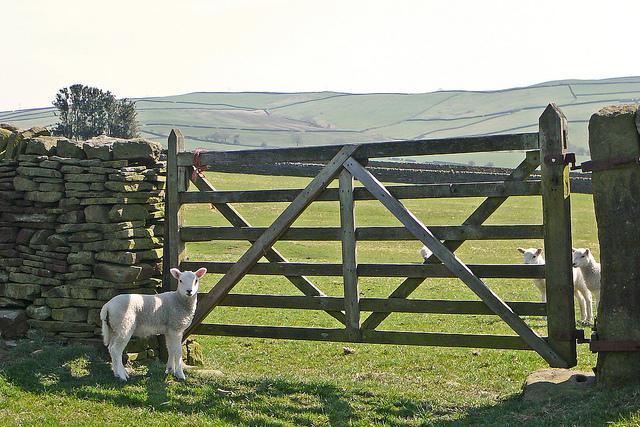How many horses are in the photo?
Give a very brief answer. 0. 